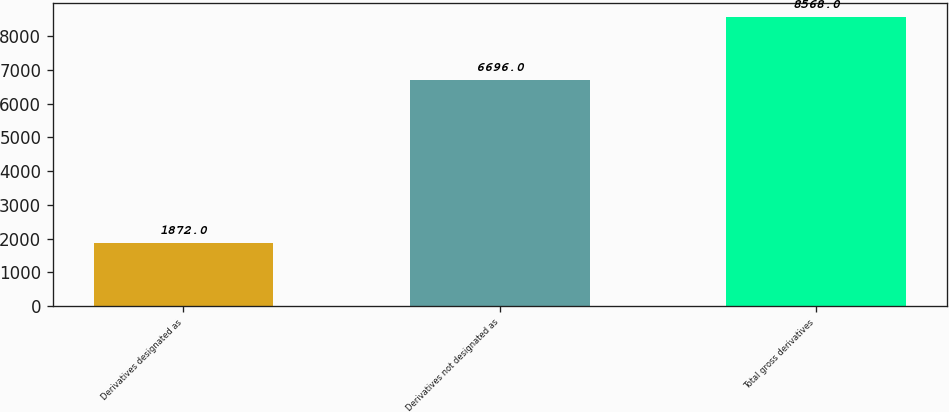<chart> <loc_0><loc_0><loc_500><loc_500><bar_chart><fcel>Derivatives designated as<fcel>Derivatives not designated as<fcel>Total gross derivatives<nl><fcel>1872<fcel>6696<fcel>8568<nl></chart> 